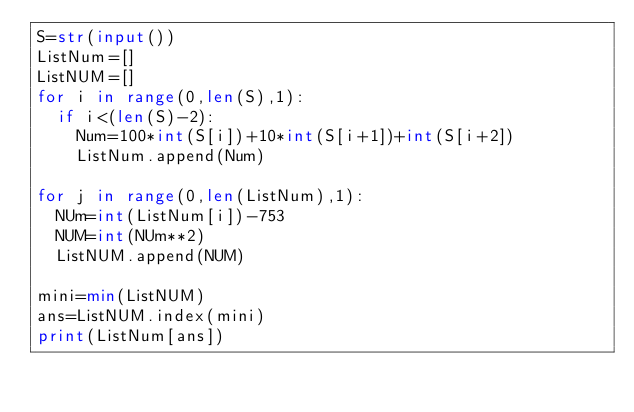Convert code to text. <code><loc_0><loc_0><loc_500><loc_500><_Python_>S=str(input())
ListNum=[]
ListNUM=[]
for i in range(0,len(S),1):
  if i<(len(S)-2):
    Num=100*int(S[i])+10*int(S[i+1])+int(S[i+2])
    ListNum.append(Num)

for j in range(0,len(ListNum),1):
  NUm=int(ListNum[i])-753
  NUM=int(NUm**2)
  ListNUM.append(NUM)

mini=min(ListNUM)
ans=ListNUM.index(mini)
print(ListNum[ans])
</code> 